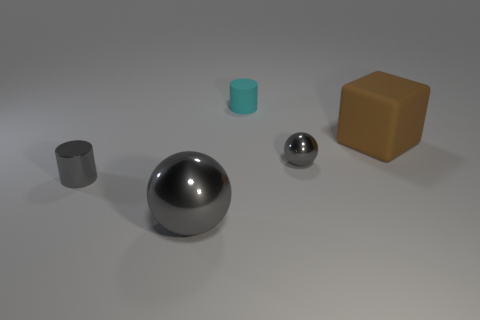Add 5 tiny spheres. How many objects exist? 10 Subtract all cylinders. How many objects are left? 3 Subtract 0 red balls. How many objects are left? 5 Subtract all cyan matte objects. Subtract all tiny cyan matte things. How many objects are left? 3 Add 3 rubber objects. How many rubber objects are left? 5 Add 5 large brown objects. How many large brown objects exist? 6 